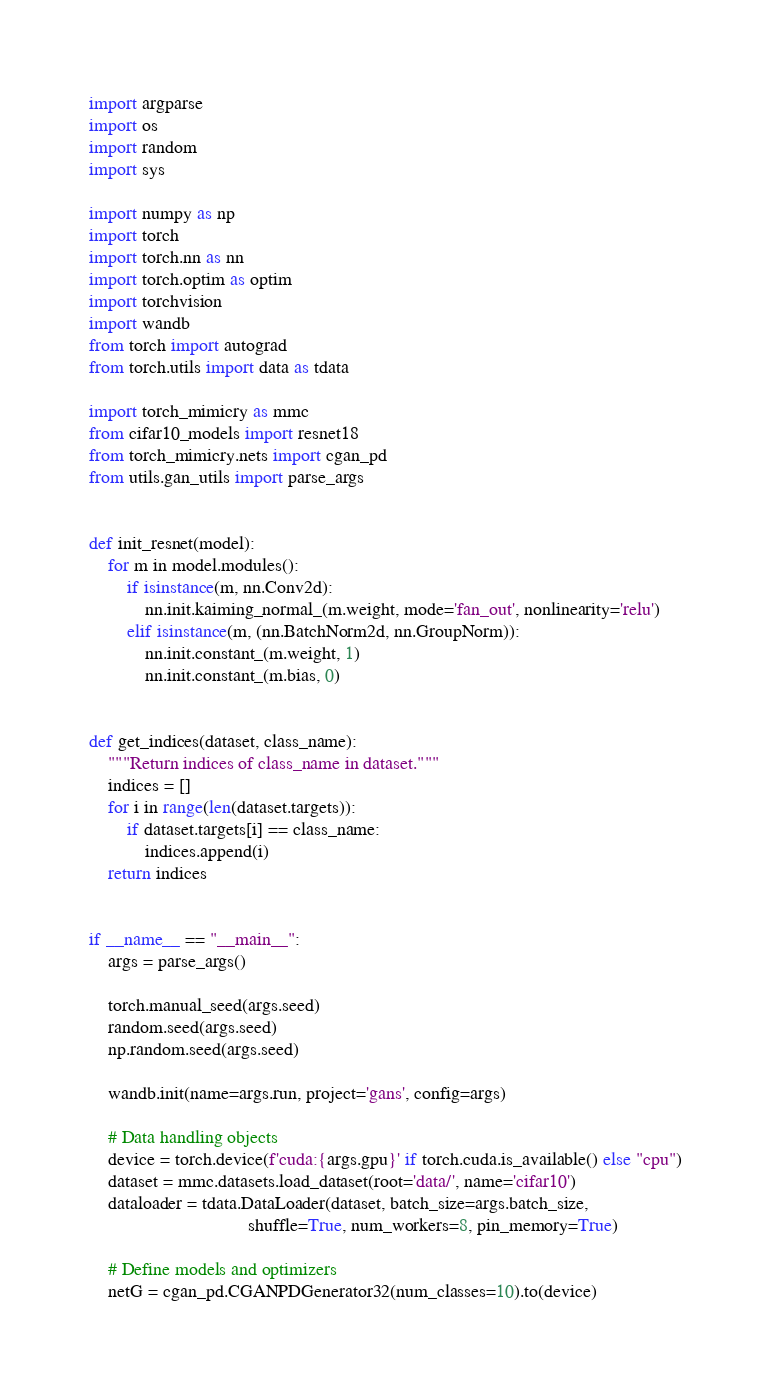<code> <loc_0><loc_0><loc_500><loc_500><_Python_>import argparse
import os
import random
import sys

import numpy as np
import torch
import torch.nn as nn
import torch.optim as optim
import torchvision
import wandb
from torch import autograd
from torch.utils import data as tdata

import torch_mimicry as mmc
from cifar10_models import resnet18
from torch_mimicry.nets import cgan_pd
from utils.gan_utils import parse_args


def init_resnet(model):
    for m in model.modules():
        if isinstance(m, nn.Conv2d):
            nn.init.kaiming_normal_(m.weight, mode='fan_out', nonlinearity='relu')
        elif isinstance(m, (nn.BatchNorm2d, nn.GroupNorm)):
            nn.init.constant_(m.weight, 1)
            nn.init.constant_(m.bias, 0)


def get_indices(dataset, class_name):
    """Return indices of class_name in dataset."""
    indices = []
    for i in range(len(dataset.targets)):
        if dataset.targets[i] == class_name:
            indices.append(i)
    return indices


if __name__ == "__main__":
    args = parse_args()

    torch.manual_seed(args.seed)
    random.seed(args.seed)
    np.random.seed(args.seed)

    wandb.init(name=args.run, project='gans', config=args)

    # Data handling objects
    device = torch.device(f'cuda:{args.gpu}' if torch.cuda.is_available() else "cpu")
    dataset = mmc.datasets.load_dataset(root='data/', name='cifar10')
    dataloader = tdata.DataLoader(dataset, batch_size=args.batch_size,
                                  shuffle=True, num_workers=8, pin_memory=True)

    # Define models and optimizers
    netG = cgan_pd.CGANPDGenerator32(num_classes=10).to(device)</code> 